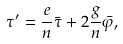Convert formula to latex. <formula><loc_0><loc_0><loc_500><loc_500>\tau ^ { \prime } = \frac { e } { n } \bar { \tau } + 2 \frac { g } { n } \bar { \varphi } ,</formula> 